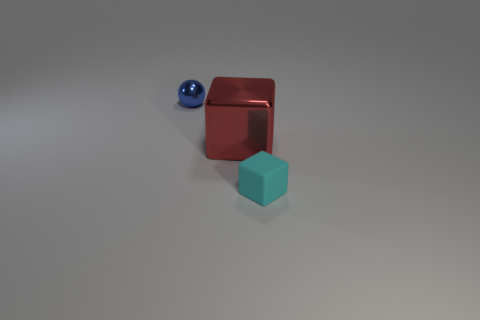How do the shadows cast by the objects help inform us about the light source? The shadows are relatively soft and extend to the right of the objects, indicating that the light source is to the left of the scene. The light source appears to be above the objects as well, given the angle at which the shadows fall. 